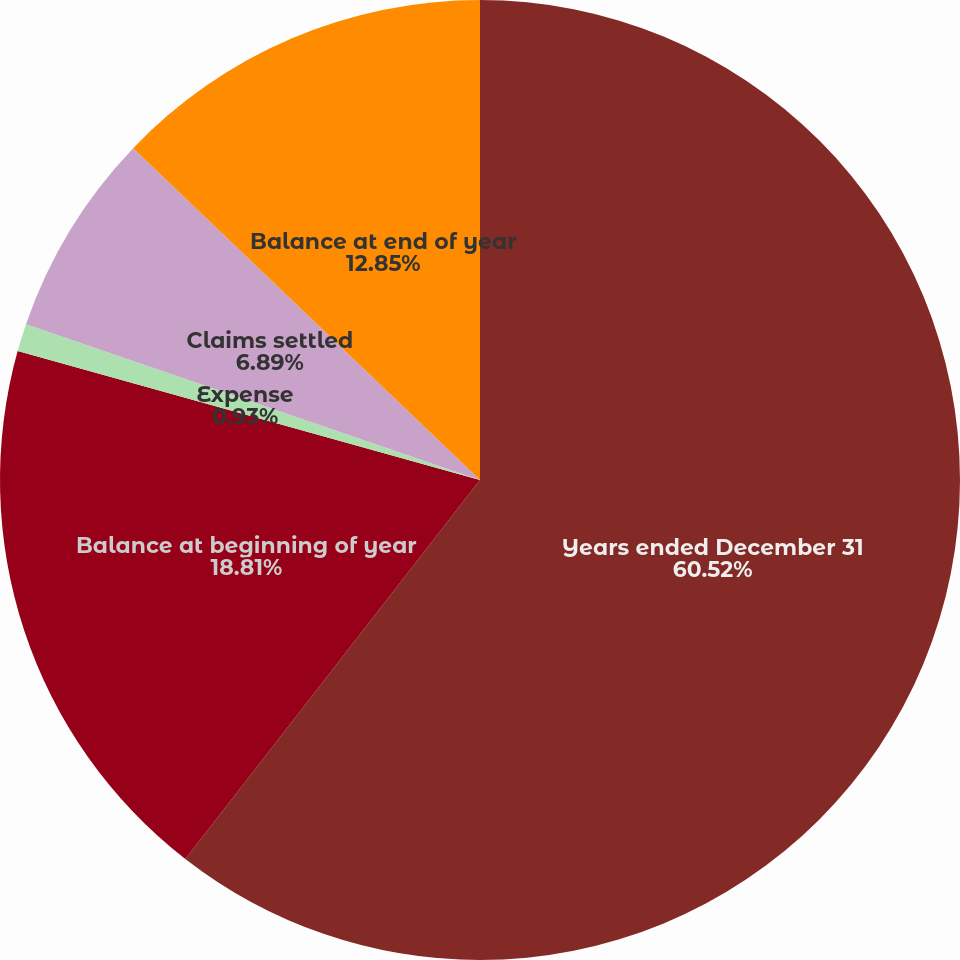Convert chart. <chart><loc_0><loc_0><loc_500><loc_500><pie_chart><fcel>Years ended December 31<fcel>Balance at beginning of year<fcel>Expense<fcel>Claims settled<fcel>Balance at end of year<nl><fcel>60.52%<fcel>18.81%<fcel>0.93%<fcel>6.89%<fcel>12.85%<nl></chart> 